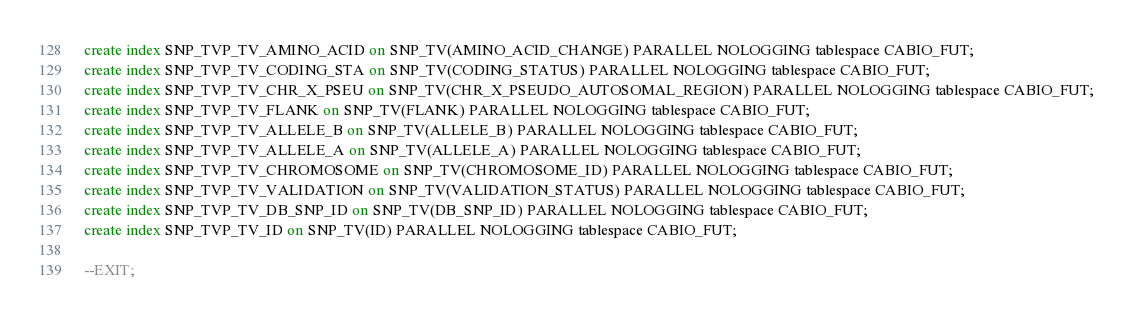Convert code to text. <code><loc_0><loc_0><loc_500><loc_500><_SQL_>
create index SNP_TVP_TV_AMINO_ACID on SNP_TV(AMINO_ACID_CHANGE) PARALLEL NOLOGGING tablespace CABIO_FUT;
create index SNP_TVP_TV_CODING_STA on SNP_TV(CODING_STATUS) PARALLEL NOLOGGING tablespace CABIO_FUT;
create index SNP_TVP_TV_CHR_X_PSEU on SNP_TV(CHR_X_PSEUDO_AUTOSOMAL_REGION) PARALLEL NOLOGGING tablespace CABIO_FUT;
create index SNP_TVP_TV_FLANK on SNP_TV(FLANK) PARALLEL NOLOGGING tablespace CABIO_FUT;
create index SNP_TVP_TV_ALLELE_B on SNP_TV(ALLELE_B) PARALLEL NOLOGGING tablespace CABIO_FUT;
create index SNP_TVP_TV_ALLELE_A on SNP_TV(ALLELE_A) PARALLEL NOLOGGING tablespace CABIO_FUT;
create index SNP_TVP_TV_CHROMOSOME on SNP_TV(CHROMOSOME_ID) PARALLEL NOLOGGING tablespace CABIO_FUT;
create index SNP_TVP_TV_VALIDATION on SNP_TV(VALIDATION_STATUS) PARALLEL NOLOGGING tablespace CABIO_FUT;
create index SNP_TVP_TV_DB_SNP_ID on SNP_TV(DB_SNP_ID) PARALLEL NOLOGGING tablespace CABIO_FUT;
create index SNP_TVP_TV_ID on SNP_TV(ID) PARALLEL NOLOGGING tablespace CABIO_FUT;

--EXIT;
</code> 